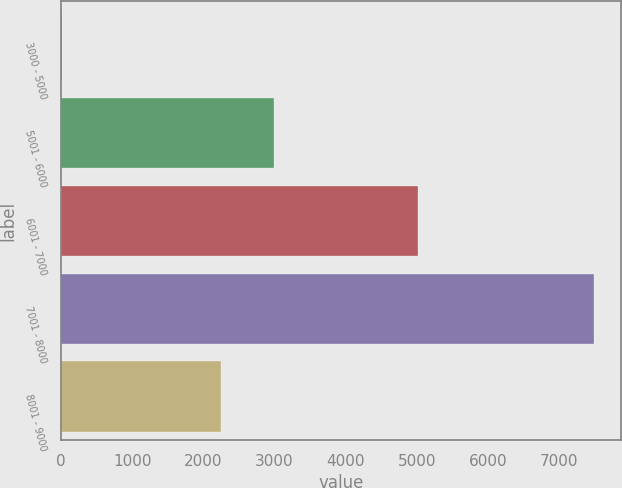<chart> <loc_0><loc_0><loc_500><loc_500><bar_chart><fcel>3000 - 5000<fcel>5001 - 6000<fcel>6001 - 7000<fcel>7001 - 8000<fcel>8001 - 9000<nl><fcel>15<fcel>2991.8<fcel>5014<fcel>7493<fcel>2244<nl></chart> 